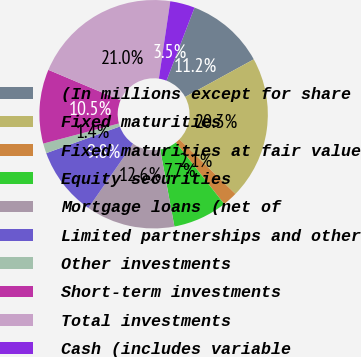Convert chart to OTSL. <chart><loc_0><loc_0><loc_500><loc_500><pie_chart><fcel>(In millions except for share<fcel>Fixed maturities<fcel>Fixed maturities at fair value<fcel>Equity securities<fcel>Mortgage loans (net of<fcel>Limited partnerships and other<fcel>Other investments<fcel>Short-term investments<fcel>Total investments<fcel>Cash (includes variable<nl><fcel>11.19%<fcel>20.28%<fcel>2.1%<fcel>7.69%<fcel>12.59%<fcel>9.79%<fcel>1.4%<fcel>10.49%<fcel>20.98%<fcel>3.5%<nl></chart> 